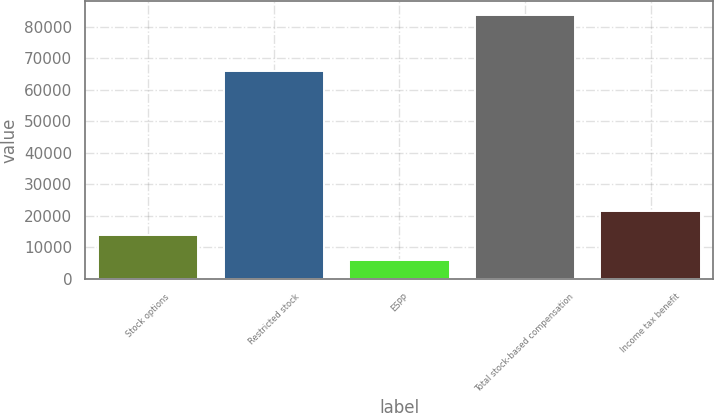<chart> <loc_0><loc_0><loc_500><loc_500><bar_chart><fcel>Stock options<fcel>Restricted stock<fcel>ESPP<fcel>Total stock-based compensation<fcel>Income tax benefit<nl><fcel>13804.4<fcel>65894<fcel>6028<fcel>83792<fcel>21580.8<nl></chart> 